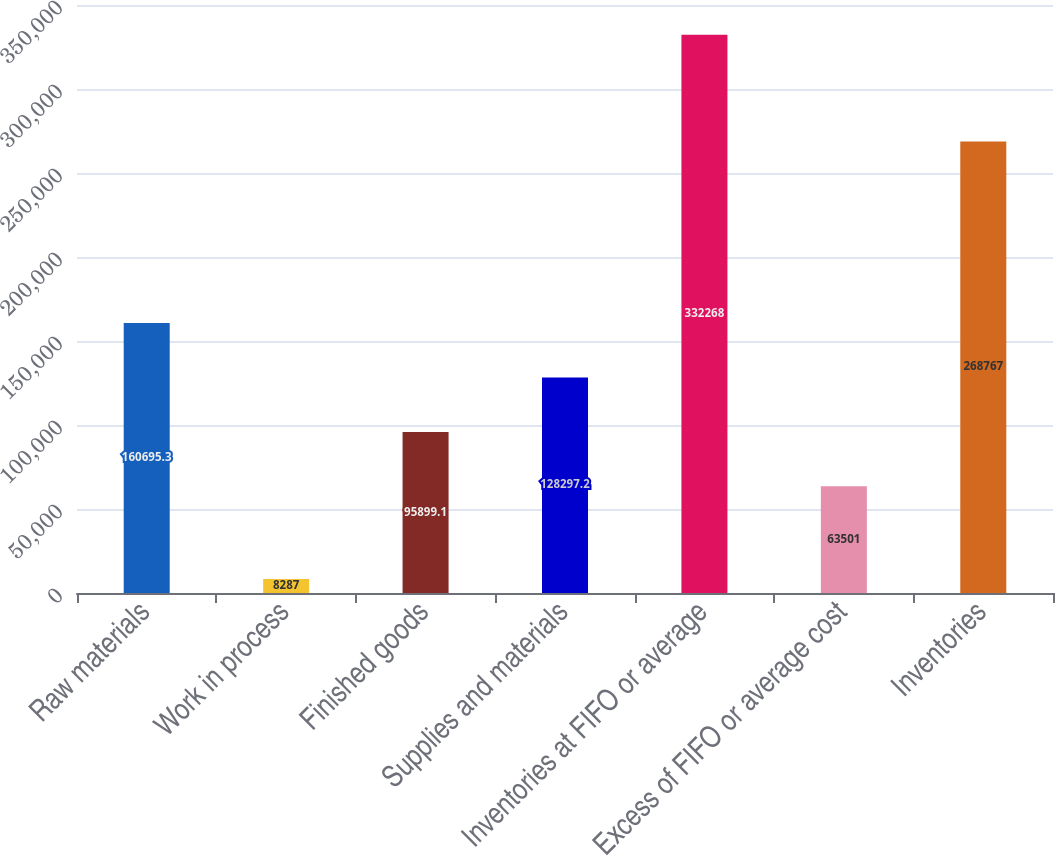<chart> <loc_0><loc_0><loc_500><loc_500><bar_chart><fcel>Raw materials<fcel>Work in process<fcel>Finished goods<fcel>Supplies and materials<fcel>Inventories at FIFO or average<fcel>Excess of FIFO or average cost<fcel>Inventories<nl><fcel>160695<fcel>8287<fcel>95899.1<fcel>128297<fcel>332268<fcel>63501<fcel>268767<nl></chart> 